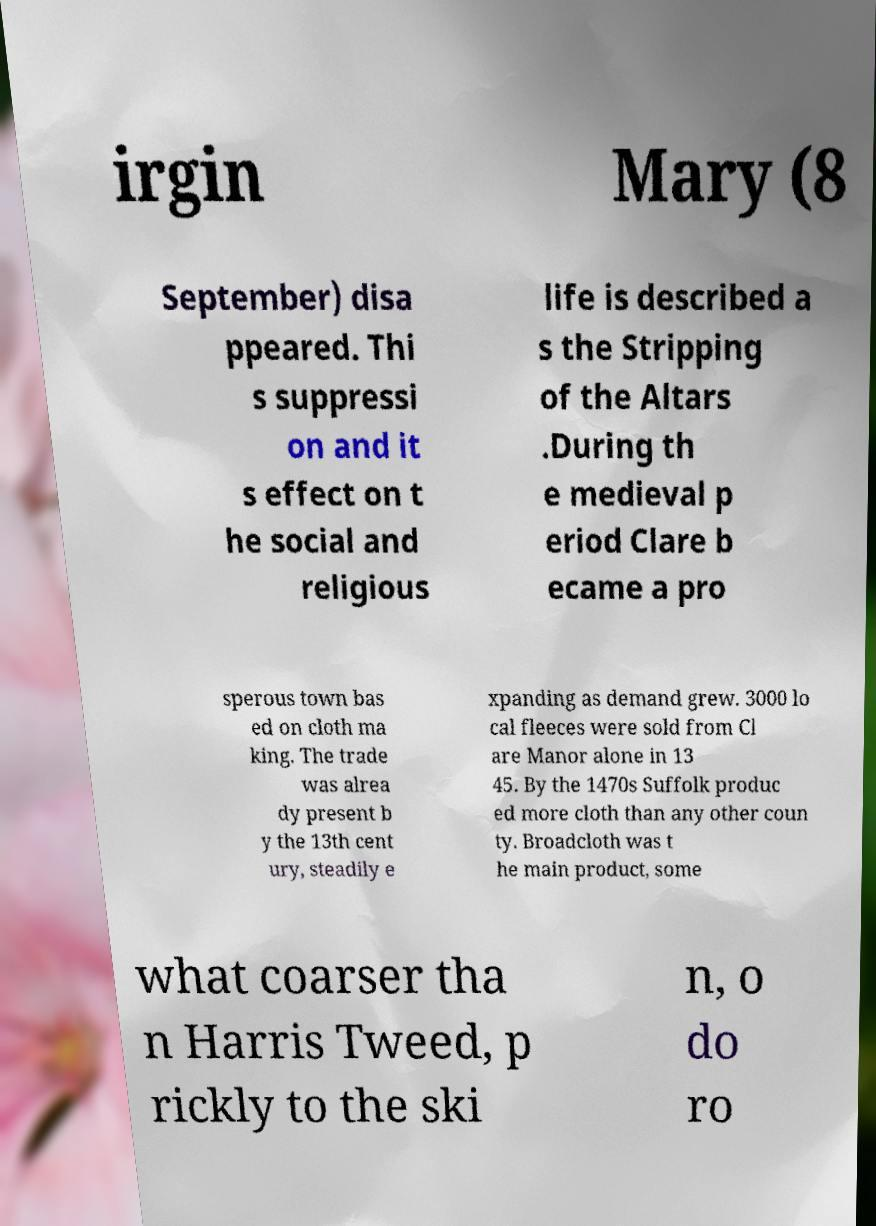For documentation purposes, I need the text within this image transcribed. Could you provide that? irgin Mary (8 September) disa ppeared. Thi s suppressi on and it s effect on t he social and religious life is described a s the Stripping of the Altars .During th e medieval p eriod Clare b ecame a pro sperous town bas ed on cloth ma king. The trade was alrea dy present b y the 13th cent ury, steadily e xpanding as demand grew. 3000 lo cal fleeces were sold from Cl are Manor alone in 13 45. By the 1470s Suffolk produc ed more cloth than any other coun ty. Broadcloth was t he main product, some what coarser tha n Harris Tweed, p rickly to the ski n, o do ro 